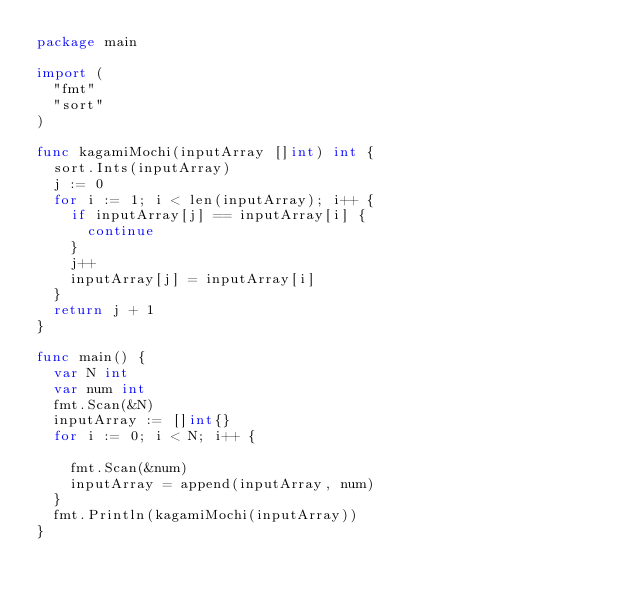Convert code to text. <code><loc_0><loc_0><loc_500><loc_500><_Go_>package main

import (
	"fmt"
	"sort"
)

func kagamiMochi(inputArray []int) int {
	sort.Ints(inputArray)
	j := 0
	for i := 1; i < len(inputArray); i++ {
		if inputArray[j] == inputArray[i] {
			continue
		}
		j++
		inputArray[j] = inputArray[i]
	}
	return j + 1
}

func main() {
	var N int
	var num int
	fmt.Scan(&N)
	inputArray := []int{}
	for i := 0; i < N; i++ {

		fmt.Scan(&num)
		inputArray = append(inputArray, num)
	}
	fmt.Println(kagamiMochi(inputArray))
}
</code> 